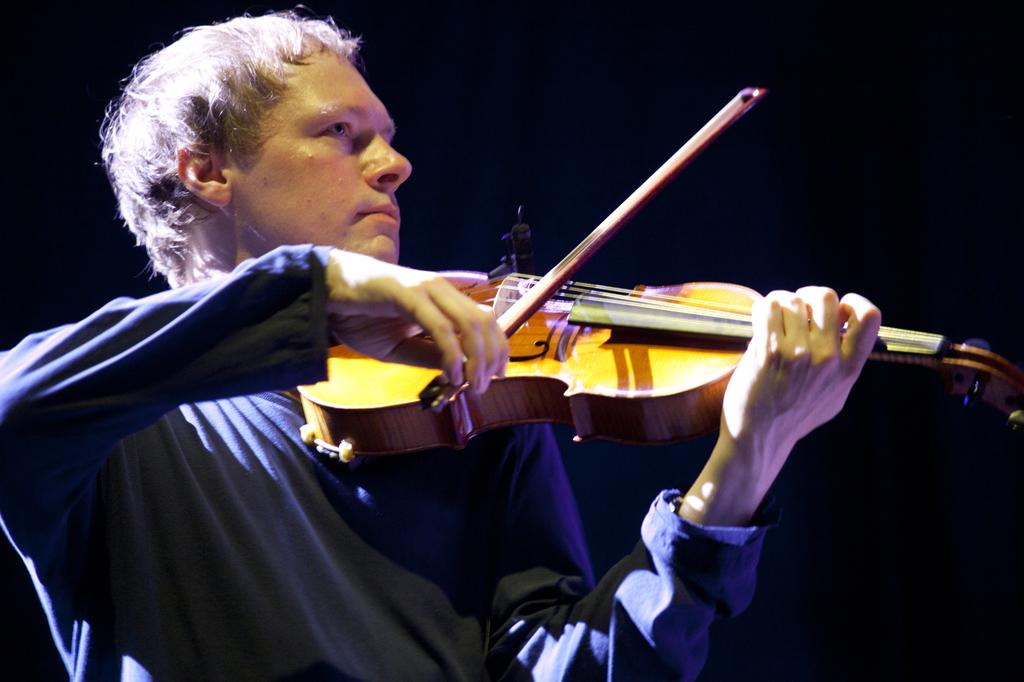What is the main subject of the image? The main subject of the image is a man. What is the man doing in the image? The man is playing a violin in the image. How many cherries can be seen on the man's face in the image? There are no cherries present on the man's face in the image. Can you describe the cow that is standing next to the man in the image? There is no cow present in the image; the man is playing a violin alone. 